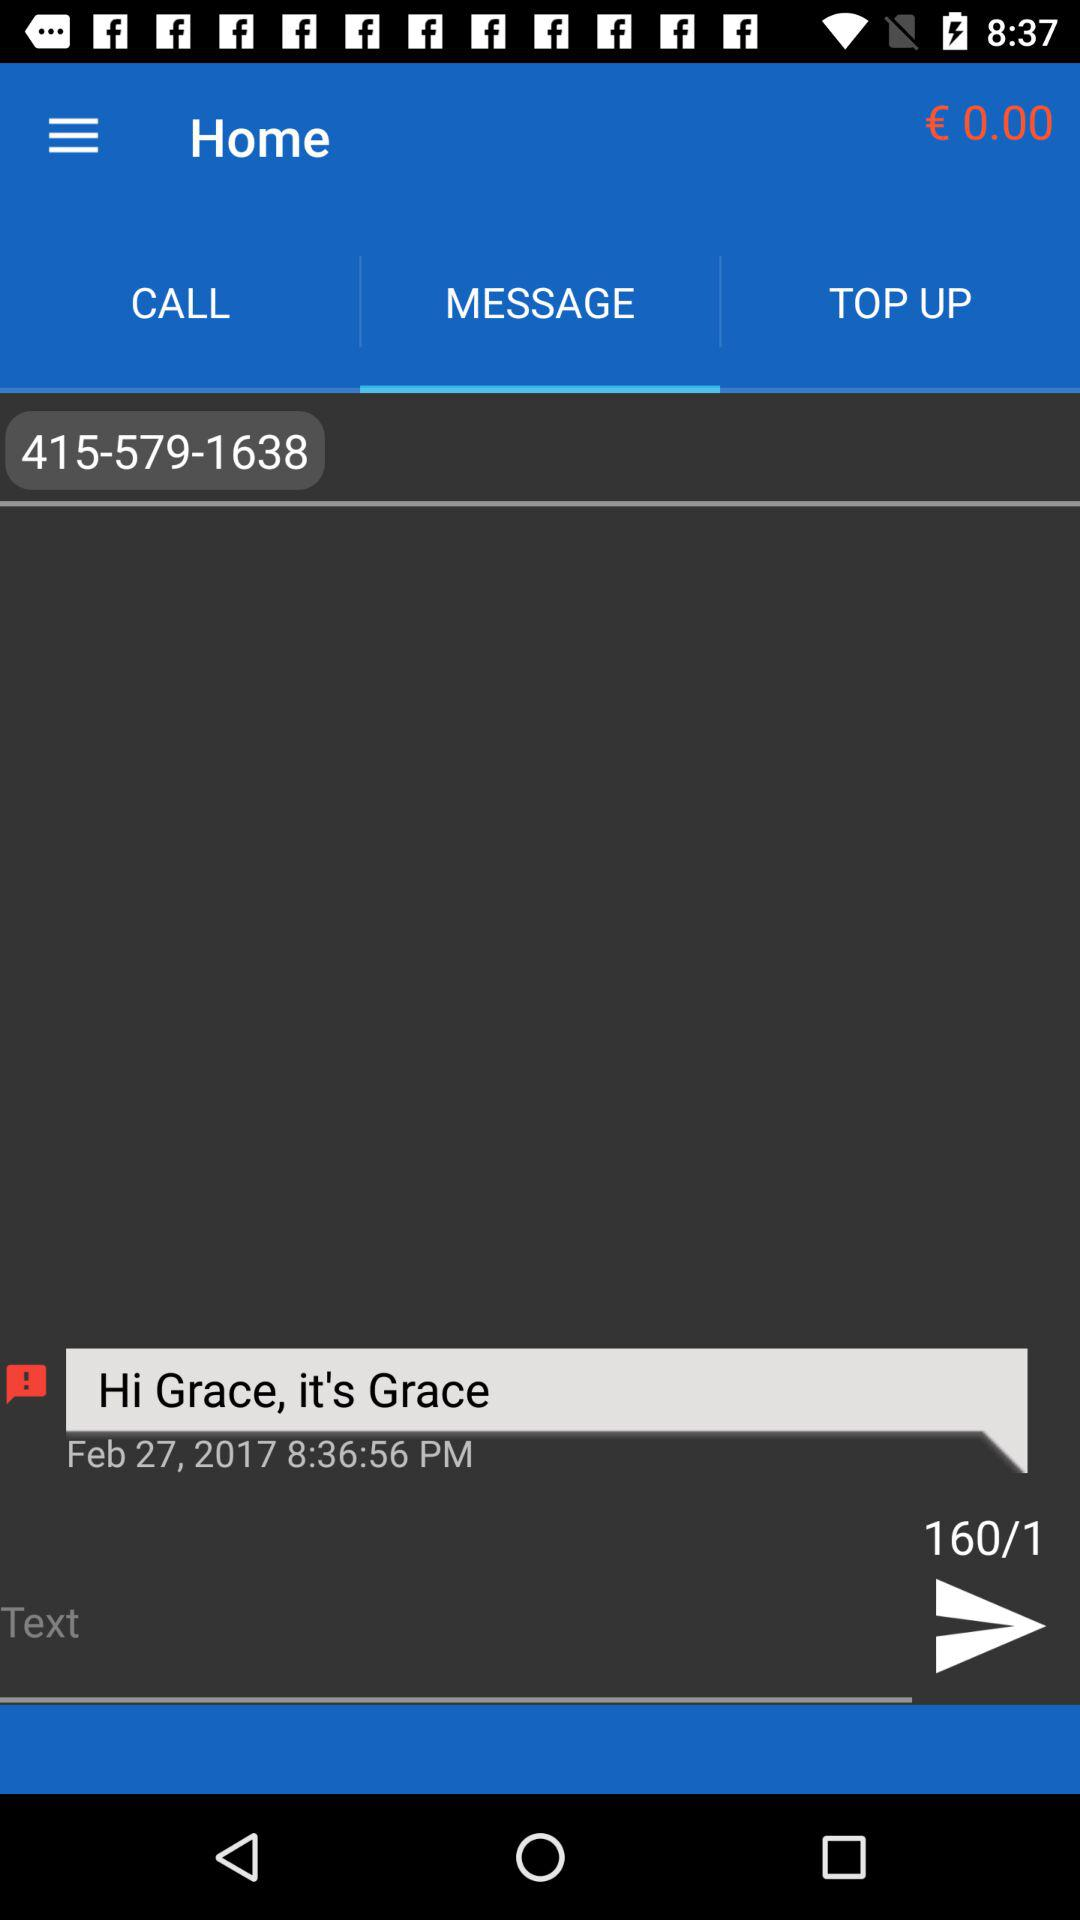What is the balance amount? The balance amount is € 0.00. 